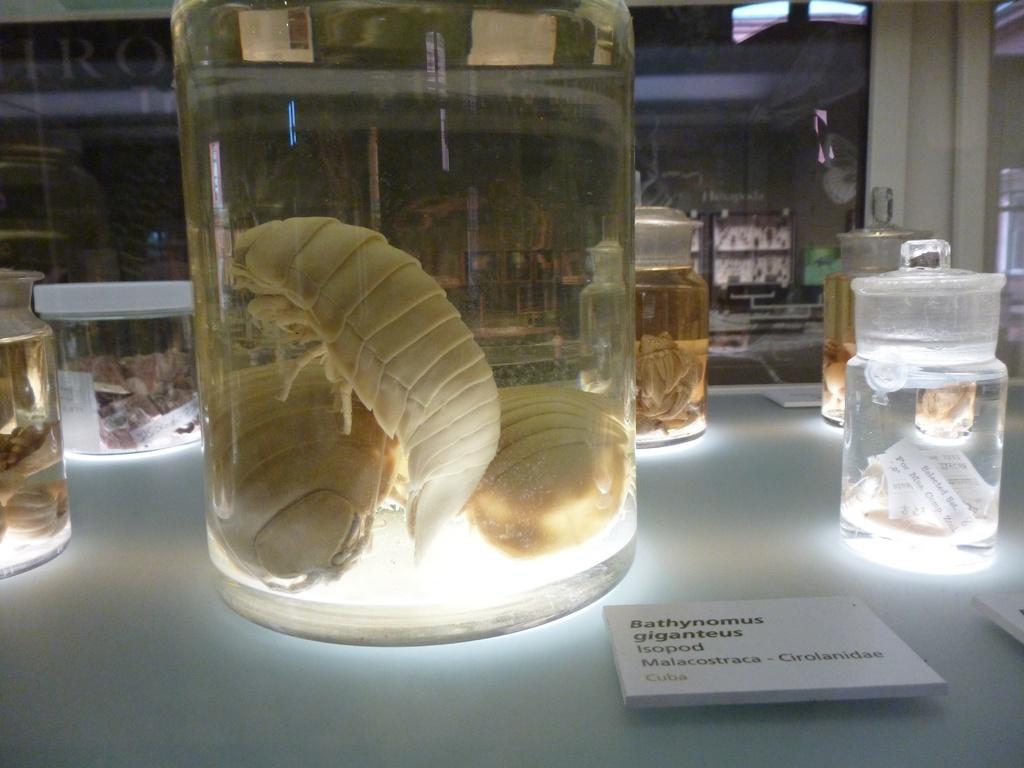What type of specimen is this?
Offer a very short reply. Bathynomus giganteus. 